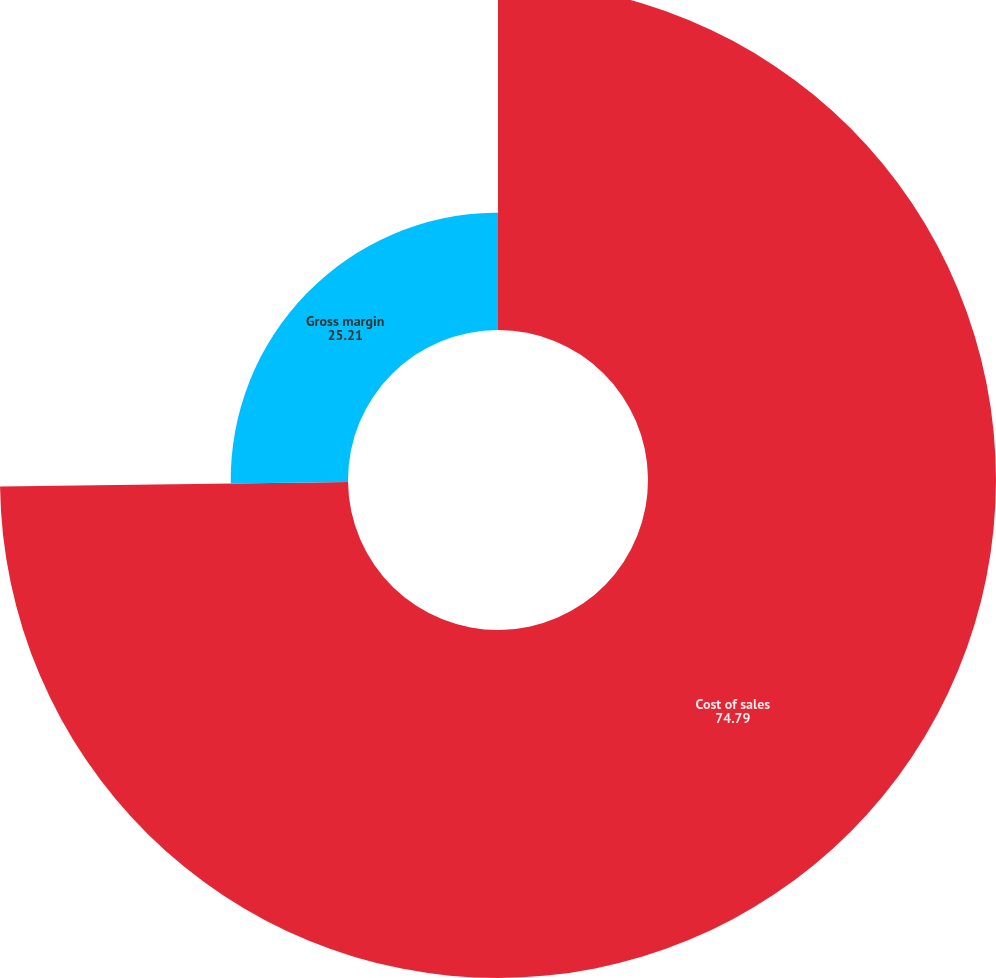<chart> <loc_0><loc_0><loc_500><loc_500><pie_chart><fcel>Cost of sales<fcel>Gross margin<nl><fcel>74.79%<fcel>25.21%<nl></chart> 